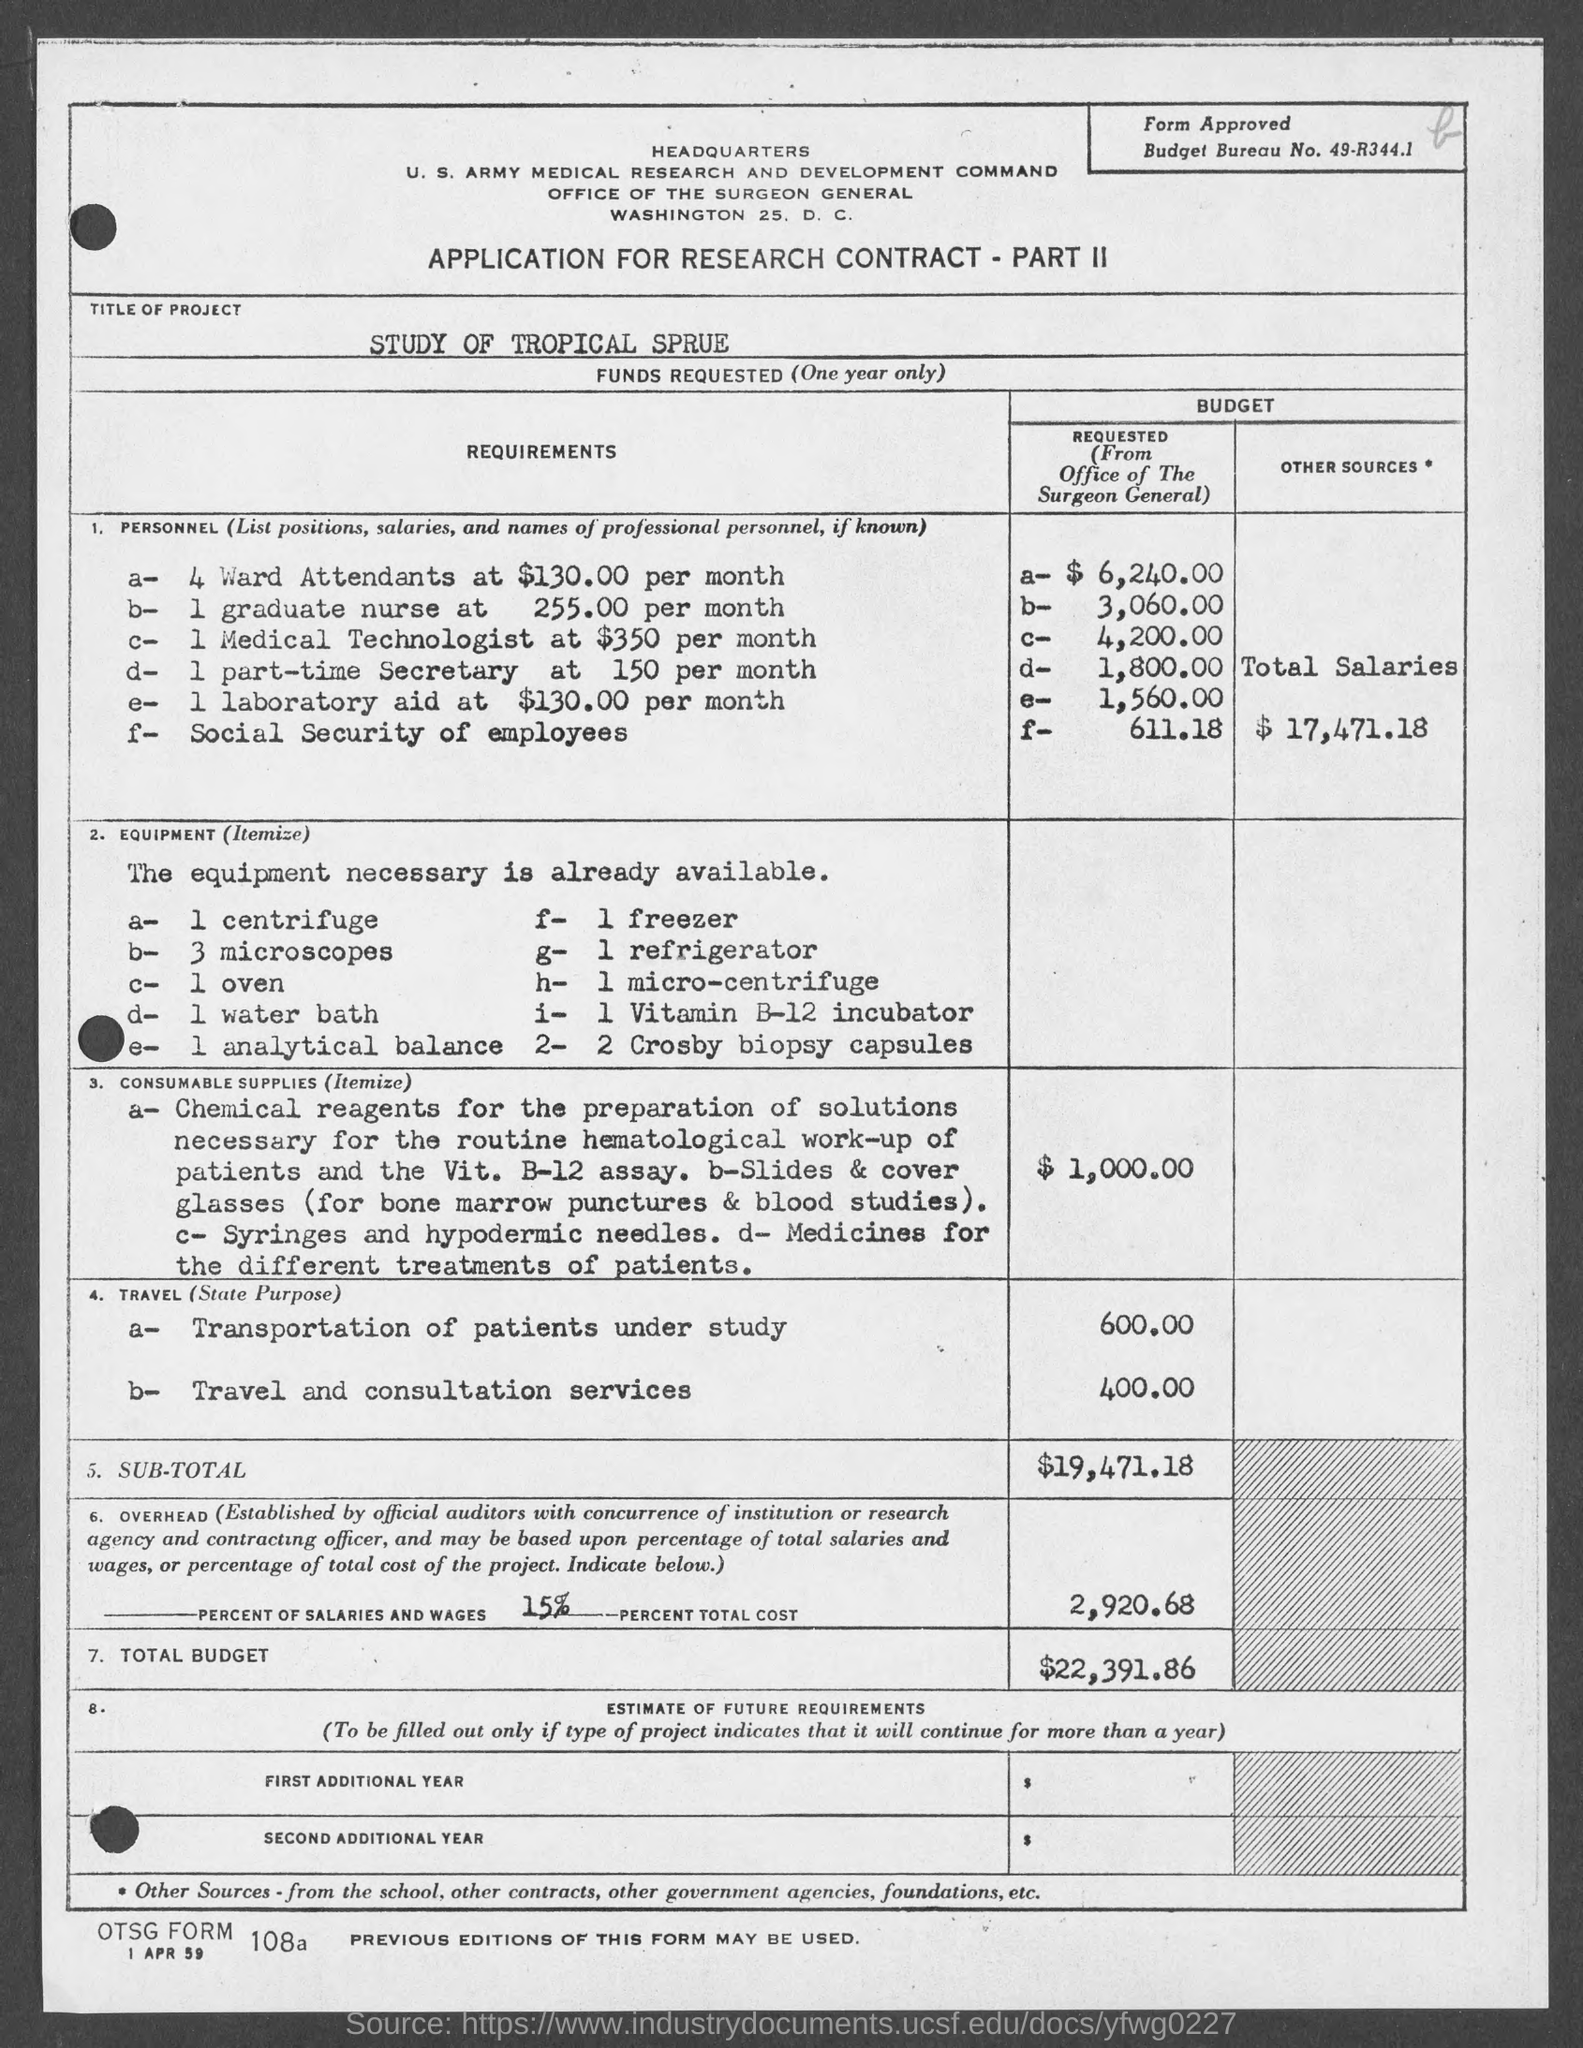What is the Title of the Project?
Give a very brief answer. Study of tropical sprue. What is the Budget Bureau No.?
Give a very brief answer. 49-R344.1. What is the total salaries for Personnel?
Make the answer very short. $ 17,471.18. What is the cost for Consumable supplies?
Make the answer very short. $ 1,000.00. What is the cost for Transportation of patients under study?
Provide a succinct answer. 600.00. What is the cost for Travel and Consultation services?
Ensure brevity in your answer.  400.00. What is the Sub-Total?
Your response must be concise. $19,471.18. What are the overhead costs?
Provide a succinct answer. 2,920.68. Whta is the Total Budget?
Your answer should be very brief. $22,391.86. 